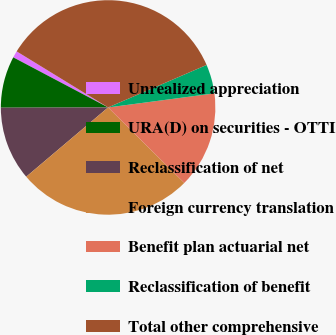Convert chart to OTSL. <chart><loc_0><loc_0><loc_500><loc_500><pie_chart><fcel>Unrealized appreciation<fcel>URA(D) on securities - OTTI<fcel>Reclassification of net<fcel>Foreign currency translation<fcel>Benefit plan actuarial net<fcel>Reclassification of benefit<fcel>Total other comprehensive<nl><fcel>1.02%<fcel>7.77%<fcel>11.14%<fcel>26.4%<fcel>14.52%<fcel>4.39%<fcel>34.77%<nl></chart> 